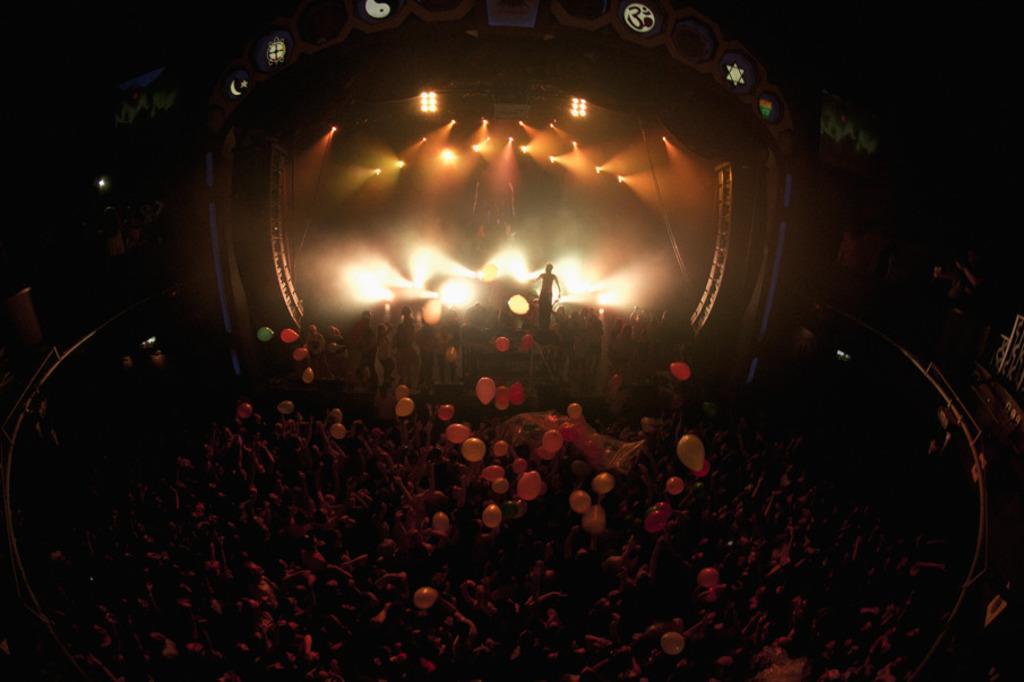Can you describe this image briefly? In this picture we can see some people standing here, there is a person standing on the stage, we can see some lights here, there are some balloons here. 